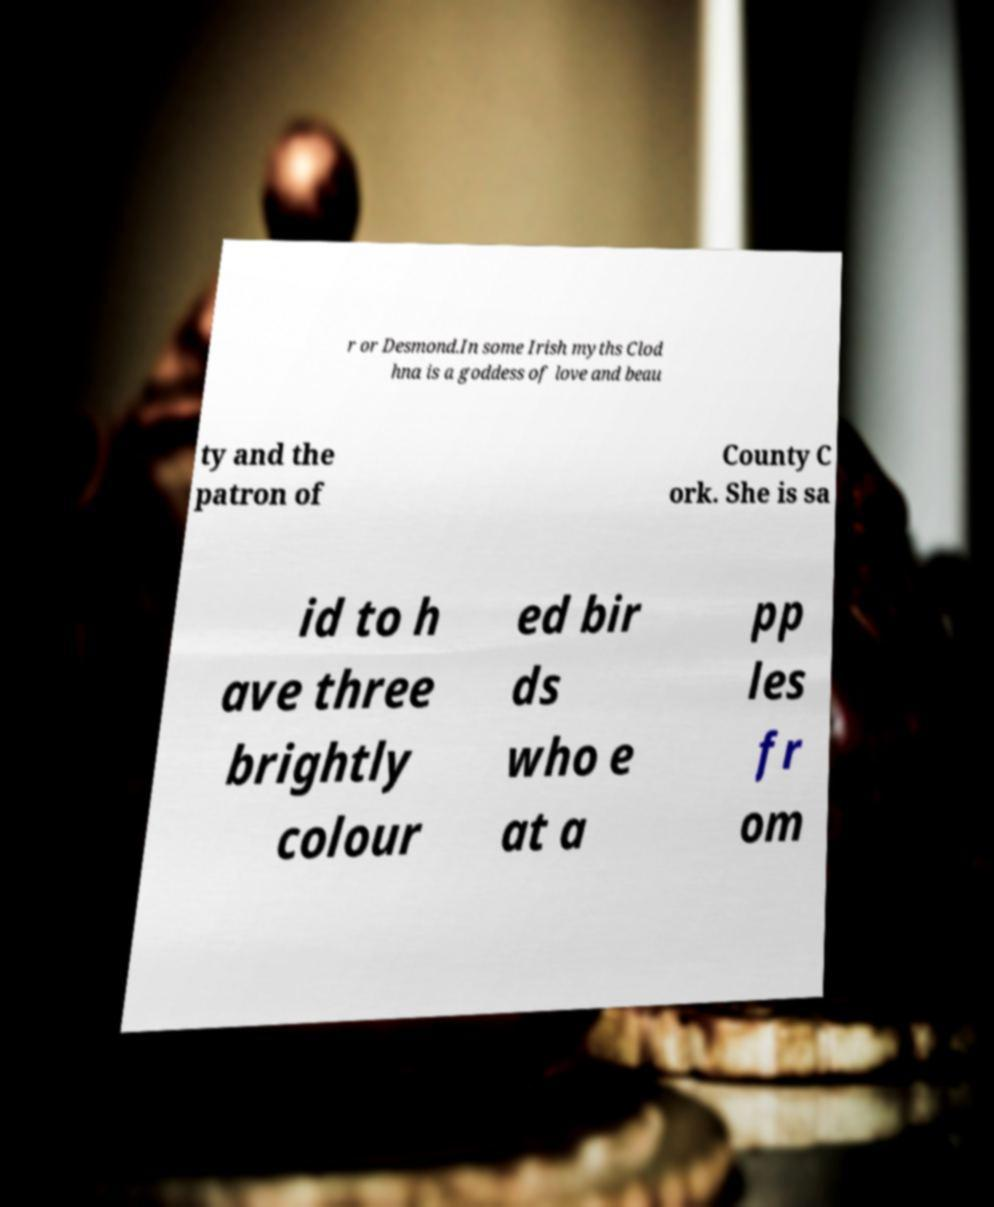Could you assist in decoding the text presented in this image and type it out clearly? r or Desmond.In some Irish myths Clod hna is a goddess of love and beau ty and the patron of County C ork. She is sa id to h ave three brightly colour ed bir ds who e at a pp les fr om 